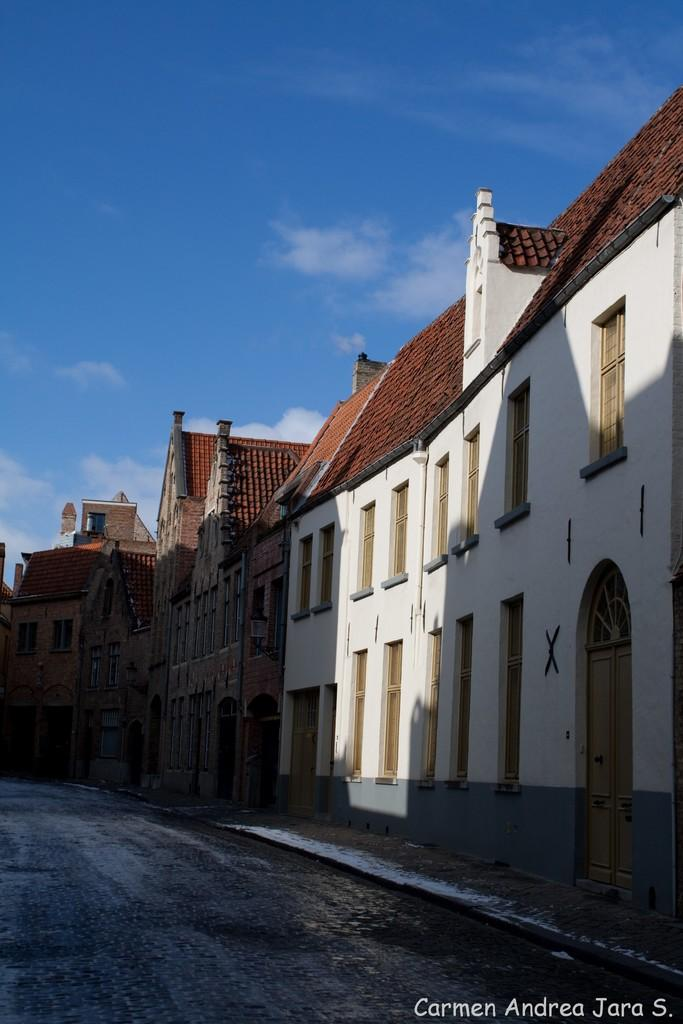What type of structures can be seen in the image? There are buildings in the image. What else is present in the image besides the buildings? There is a road in the image. What can be seen in the background of the image? The sky is visible in the background of the image. Is there any text or marking present in the image? Yes, there is a watermark at the bottom right side of the image. What type of vessel is being used in the image? There is no vessel present in the image. Can you describe the home in the image? The image does not show a home; it features buildings and a road. 